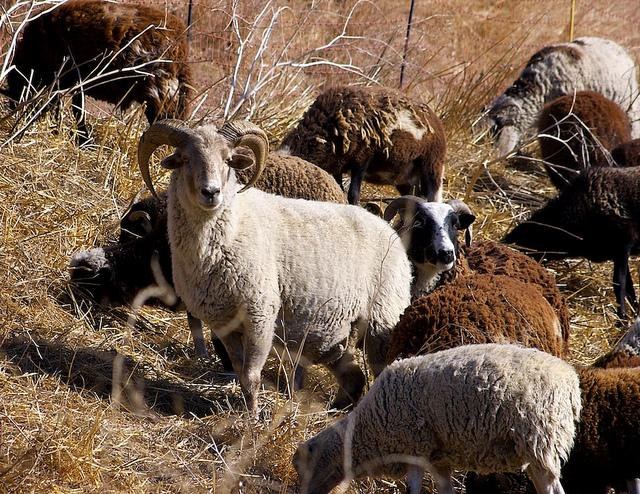Why are the sheep difference colors? Please explain your reasoning. breed. They are different types of the same animal. 